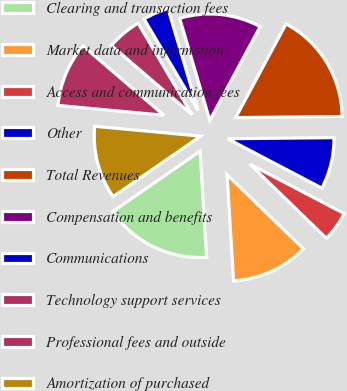<chart> <loc_0><loc_0><loc_500><loc_500><pie_chart><fcel>Clearing and transaction fees<fcel>Market data and information<fcel>Access and communication fees<fcel>Other<fcel>Total Revenues<fcel>Compensation and benefits<fcel>Communications<fcel>Technology support services<fcel>Professional fees and outside<fcel>Amortization of purchased<nl><fcel>16.34%<fcel>11.76%<fcel>4.58%<fcel>7.84%<fcel>16.99%<fcel>12.42%<fcel>3.92%<fcel>5.23%<fcel>9.8%<fcel>11.11%<nl></chart> 